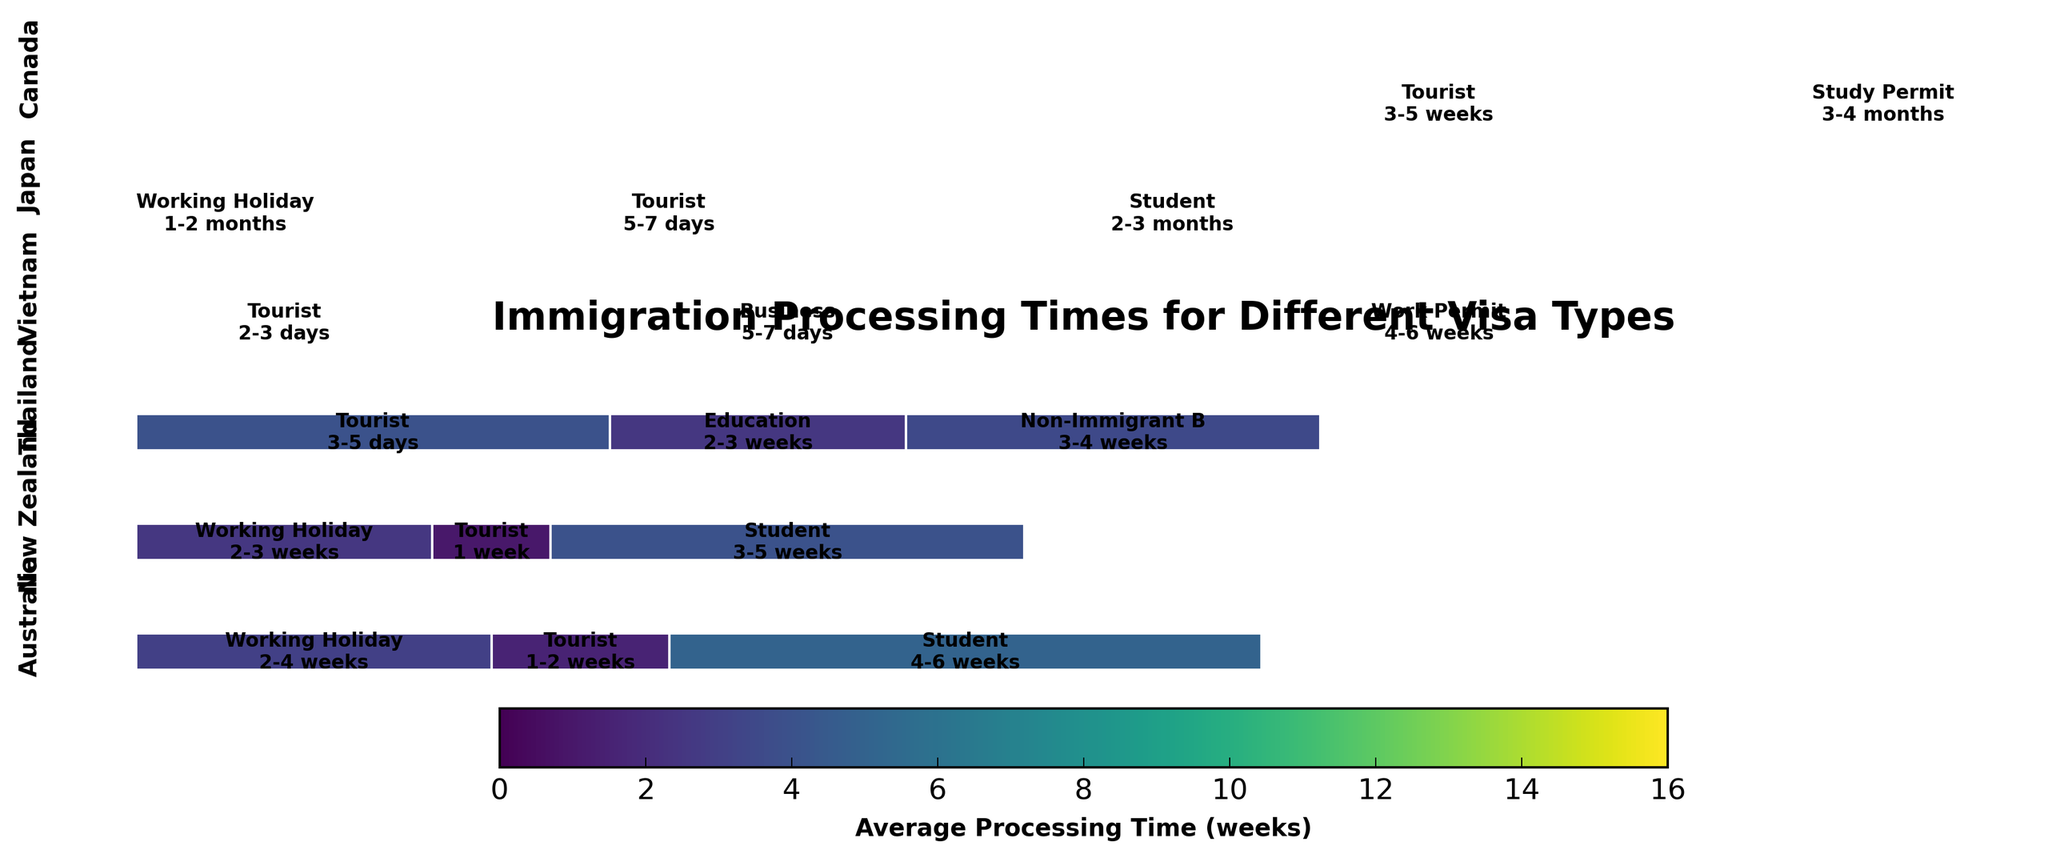What's the title of the plot? The title is usually displayed at the top of the plot and summarizes the main data presented. In this case, it is "Immigration Processing Times for Different Visa Types".
Answer: Immigration Processing Times for Different Visa Types Which country has the longest average processing time for Student visas? To determine this, look for the width of the rectangles representing Student visas across countries. The wider the rectangle, the longer the average processing time. Japan's Student visa has the widest rectangle, indicating the longest time.
Answer: Japan Compare the average processing times for Working Holiday visas between Australia, New Zealand, Japan, and Canada. Which country has the shortest processing time? Look at the widths of the rectangles labeled Working Holiday for these countries. Australia's rectangle is the narrowest among them, indicating the shortest average processing time.
Answer: Australia How does Thailand's Tourist visa processing time compare to Vietnam's Tourist visa processing time? Check the width and color intensity of rectangles for Tourist visas in Thailand and Vietnam. Vietnam has a narrower and lighter-colored rectangle indicating a shorter processing time.
Answer: Vietnam is shorter What is the average processing time range for Canada's Study Permit? The text inside Canada's Study Permit rectangle provides this information. It reads "3-4 months", indicating the processing time range.
Answer: 3-4 months For which visa type does Thailand have the longest processing time? Identify the visa type in Thailand with the widest rectangle. The widest rectangle is labeled "Non-Immigrant B", indicating the longest processing time.
Answer: Non-Immigrant B Which country has the most variety in visa types shown in the plot? Count the different visa types per country by checking the labels within the country's section. Australia, Japan, and Canada each have multiple types, but Canada shows a broader variety.
Answer: Canada Which visa type generally seems to have the shortest processing times across most countries? Compare the widths of rectangles for all visa types to identify which are consistently narrow. Tourist visas generally have the shortest processing times across most countries.
Answer: Tourist What is the most common range for Tourist visa processing times among the countries shown? Examine the processing times labeled in the Tourist visa rectangles for commonality. Most Tourist visa processing times range from a few days to about a week.
Answer: A few days to a week 